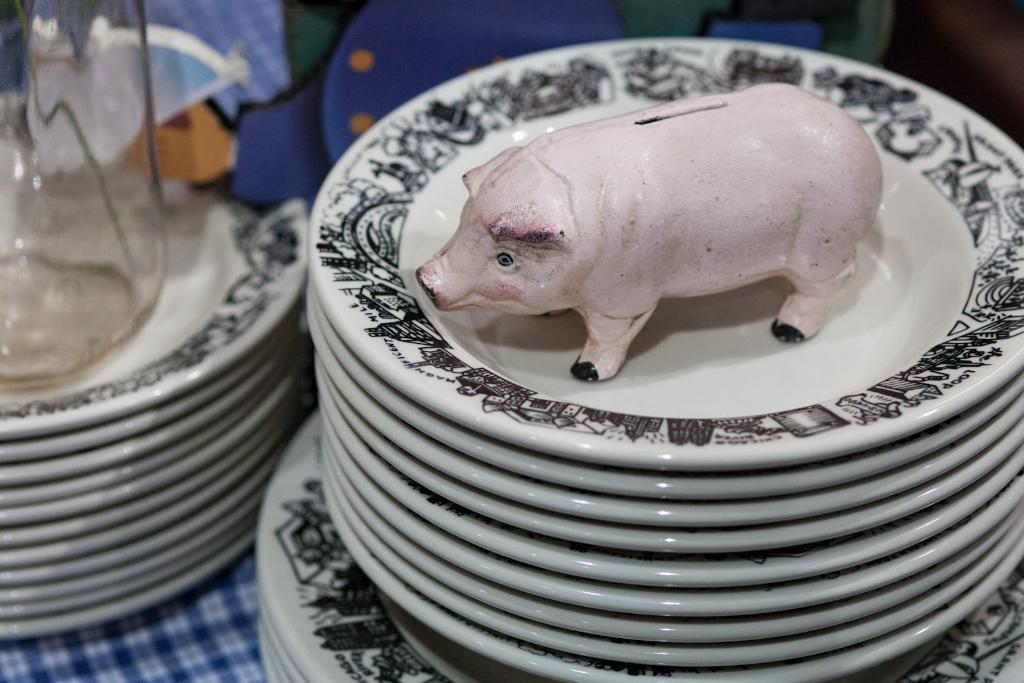What objects are on the table in the image? There are plates on a table in the image. What is located at the top of the image? There is a piggy bank present at the top of the image. Where is the glass jar situated in the image? The glass jar is on the left side of the image. What type of rock can be seen at the seashore in the image? There is no seashore or rock present in the image. How many cherries are on the plates in the image? The provided facts do not mention cherries, so we cannot determine their presence or quantity in the image. 